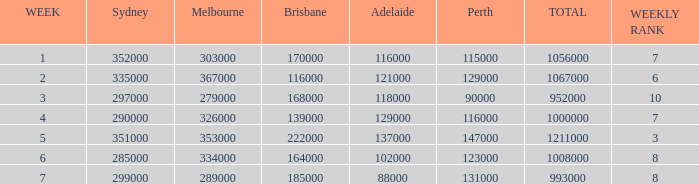How many episodes aired in Sydney in Week 3? 1.0. 